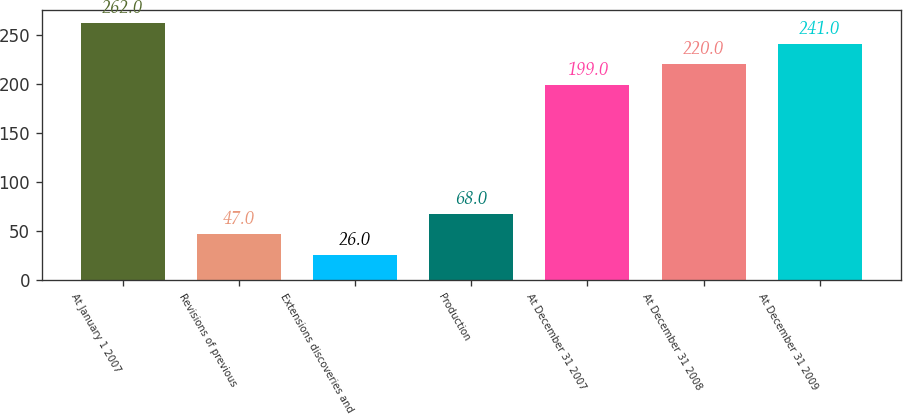Convert chart. <chart><loc_0><loc_0><loc_500><loc_500><bar_chart><fcel>At January 1 2007<fcel>Revisions of previous<fcel>Extensions discoveries and<fcel>Production<fcel>At December 31 2007<fcel>At December 31 2008<fcel>At December 31 2009<nl><fcel>262<fcel>47<fcel>26<fcel>68<fcel>199<fcel>220<fcel>241<nl></chart> 